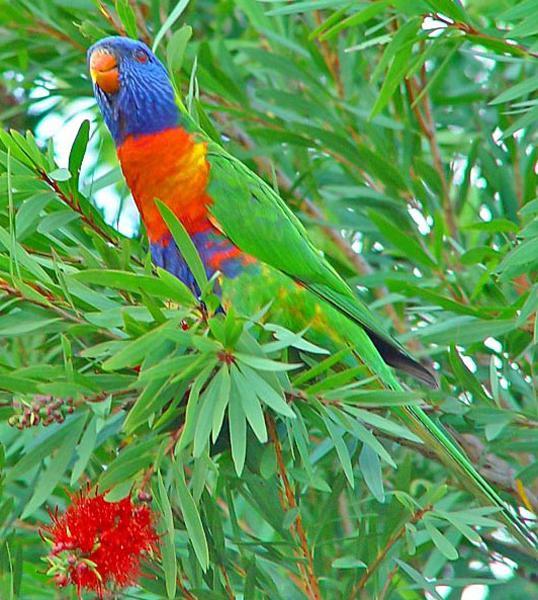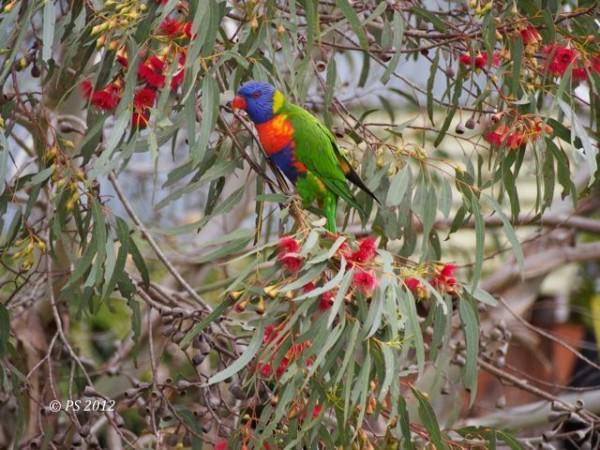The first image is the image on the left, the second image is the image on the right. For the images shown, is this caption "There are two birds" true? Answer yes or no. Yes. 